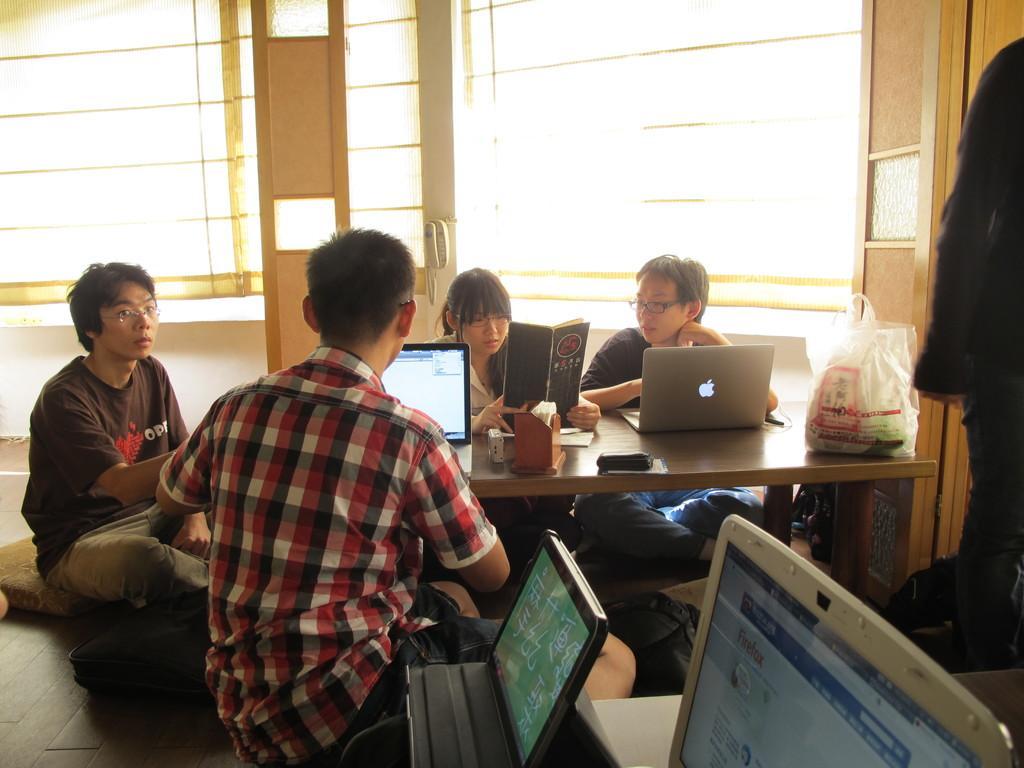Could you give a brief overview of what you see in this image? In this image there are people. There is a laptop at the front. A person is facing his back and he is operating the laptop. On the table there are plastic covers. And other three people, behind them there is a window. 